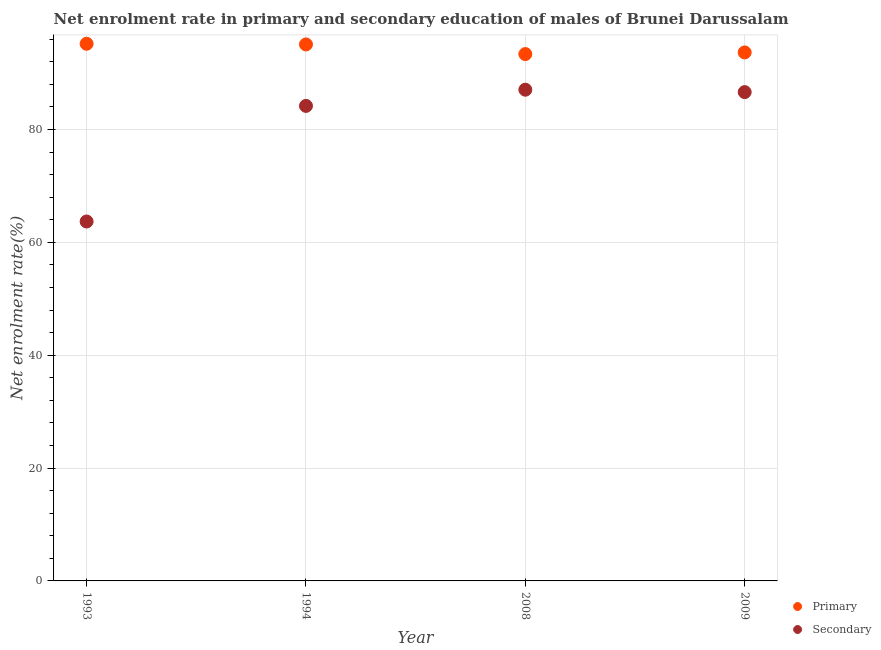How many different coloured dotlines are there?
Provide a succinct answer. 2. What is the enrollment rate in secondary education in 1993?
Ensure brevity in your answer.  63.7. Across all years, what is the maximum enrollment rate in primary education?
Your answer should be compact. 95.19. Across all years, what is the minimum enrollment rate in secondary education?
Offer a very short reply. 63.7. In which year was the enrollment rate in primary education minimum?
Give a very brief answer. 2008. What is the total enrollment rate in secondary education in the graph?
Offer a terse response. 321.56. What is the difference between the enrollment rate in primary education in 1994 and that in 2008?
Offer a very short reply. 1.71. What is the difference between the enrollment rate in primary education in 1993 and the enrollment rate in secondary education in 2008?
Your answer should be very brief. 8.14. What is the average enrollment rate in primary education per year?
Make the answer very short. 94.32. In the year 1994, what is the difference between the enrollment rate in primary education and enrollment rate in secondary education?
Your response must be concise. 10.89. In how many years, is the enrollment rate in primary education greater than 24 %?
Offer a terse response. 4. What is the ratio of the enrollment rate in primary education in 1994 to that in 2009?
Keep it short and to the point. 1.02. Is the enrollment rate in primary education in 1993 less than that in 2008?
Offer a terse response. No. What is the difference between the highest and the second highest enrollment rate in secondary education?
Ensure brevity in your answer.  0.43. What is the difference between the highest and the lowest enrollment rate in secondary education?
Give a very brief answer. 23.35. Is the enrollment rate in secondary education strictly less than the enrollment rate in primary education over the years?
Provide a short and direct response. Yes. How many dotlines are there?
Keep it short and to the point. 2. How many years are there in the graph?
Your answer should be very brief. 4. How many legend labels are there?
Keep it short and to the point. 2. What is the title of the graph?
Make the answer very short. Net enrolment rate in primary and secondary education of males of Brunei Darussalam. What is the label or title of the X-axis?
Your response must be concise. Year. What is the label or title of the Y-axis?
Ensure brevity in your answer.  Net enrolment rate(%). What is the Net enrolment rate(%) in Primary in 1993?
Offer a very short reply. 95.19. What is the Net enrolment rate(%) of Secondary in 1993?
Provide a succinct answer. 63.7. What is the Net enrolment rate(%) of Primary in 1994?
Your answer should be very brief. 95.08. What is the Net enrolment rate(%) of Secondary in 1994?
Provide a succinct answer. 84.18. What is the Net enrolment rate(%) in Primary in 2008?
Your response must be concise. 93.37. What is the Net enrolment rate(%) of Secondary in 2008?
Give a very brief answer. 87.05. What is the Net enrolment rate(%) of Primary in 2009?
Give a very brief answer. 93.66. What is the Net enrolment rate(%) of Secondary in 2009?
Provide a succinct answer. 86.63. Across all years, what is the maximum Net enrolment rate(%) of Primary?
Your answer should be very brief. 95.19. Across all years, what is the maximum Net enrolment rate(%) in Secondary?
Keep it short and to the point. 87.05. Across all years, what is the minimum Net enrolment rate(%) in Primary?
Provide a short and direct response. 93.37. Across all years, what is the minimum Net enrolment rate(%) in Secondary?
Your answer should be compact. 63.7. What is the total Net enrolment rate(%) of Primary in the graph?
Provide a succinct answer. 377.3. What is the total Net enrolment rate(%) of Secondary in the graph?
Your answer should be very brief. 321.56. What is the difference between the Net enrolment rate(%) of Primary in 1993 and that in 1994?
Make the answer very short. 0.12. What is the difference between the Net enrolment rate(%) in Secondary in 1993 and that in 1994?
Ensure brevity in your answer.  -20.49. What is the difference between the Net enrolment rate(%) of Primary in 1993 and that in 2008?
Offer a terse response. 1.83. What is the difference between the Net enrolment rate(%) of Secondary in 1993 and that in 2008?
Give a very brief answer. -23.35. What is the difference between the Net enrolment rate(%) of Primary in 1993 and that in 2009?
Ensure brevity in your answer.  1.54. What is the difference between the Net enrolment rate(%) in Secondary in 1993 and that in 2009?
Your answer should be compact. -22.93. What is the difference between the Net enrolment rate(%) in Primary in 1994 and that in 2008?
Your answer should be very brief. 1.71. What is the difference between the Net enrolment rate(%) of Secondary in 1994 and that in 2008?
Provide a succinct answer. -2.87. What is the difference between the Net enrolment rate(%) of Primary in 1994 and that in 2009?
Your response must be concise. 1.42. What is the difference between the Net enrolment rate(%) in Secondary in 1994 and that in 2009?
Keep it short and to the point. -2.44. What is the difference between the Net enrolment rate(%) of Primary in 2008 and that in 2009?
Provide a short and direct response. -0.29. What is the difference between the Net enrolment rate(%) of Secondary in 2008 and that in 2009?
Keep it short and to the point. 0.43. What is the difference between the Net enrolment rate(%) of Primary in 1993 and the Net enrolment rate(%) of Secondary in 1994?
Provide a short and direct response. 11.01. What is the difference between the Net enrolment rate(%) of Primary in 1993 and the Net enrolment rate(%) of Secondary in 2008?
Offer a very short reply. 8.14. What is the difference between the Net enrolment rate(%) in Primary in 1993 and the Net enrolment rate(%) in Secondary in 2009?
Offer a terse response. 8.57. What is the difference between the Net enrolment rate(%) of Primary in 1994 and the Net enrolment rate(%) of Secondary in 2008?
Your answer should be compact. 8.02. What is the difference between the Net enrolment rate(%) in Primary in 1994 and the Net enrolment rate(%) in Secondary in 2009?
Make the answer very short. 8.45. What is the difference between the Net enrolment rate(%) in Primary in 2008 and the Net enrolment rate(%) in Secondary in 2009?
Ensure brevity in your answer.  6.74. What is the average Net enrolment rate(%) of Primary per year?
Offer a terse response. 94.32. What is the average Net enrolment rate(%) in Secondary per year?
Offer a terse response. 80.39. In the year 1993, what is the difference between the Net enrolment rate(%) of Primary and Net enrolment rate(%) of Secondary?
Provide a succinct answer. 31.5. In the year 1994, what is the difference between the Net enrolment rate(%) in Primary and Net enrolment rate(%) in Secondary?
Make the answer very short. 10.89. In the year 2008, what is the difference between the Net enrolment rate(%) of Primary and Net enrolment rate(%) of Secondary?
Ensure brevity in your answer.  6.31. In the year 2009, what is the difference between the Net enrolment rate(%) of Primary and Net enrolment rate(%) of Secondary?
Keep it short and to the point. 7.03. What is the ratio of the Net enrolment rate(%) in Secondary in 1993 to that in 1994?
Give a very brief answer. 0.76. What is the ratio of the Net enrolment rate(%) of Primary in 1993 to that in 2008?
Give a very brief answer. 1.02. What is the ratio of the Net enrolment rate(%) of Secondary in 1993 to that in 2008?
Make the answer very short. 0.73. What is the ratio of the Net enrolment rate(%) in Primary in 1993 to that in 2009?
Offer a very short reply. 1.02. What is the ratio of the Net enrolment rate(%) of Secondary in 1993 to that in 2009?
Provide a short and direct response. 0.74. What is the ratio of the Net enrolment rate(%) of Primary in 1994 to that in 2008?
Ensure brevity in your answer.  1.02. What is the ratio of the Net enrolment rate(%) in Secondary in 1994 to that in 2008?
Your answer should be compact. 0.97. What is the ratio of the Net enrolment rate(%) in Primary in 1994 to that in 2009?
Ensure brevity in your answer.  1.02. What is the ratio of the Net enrolment rate(%) in Secondary in 1994 to that in 2009?
Offer a terse response. 0.97. What is the ratio of the Net enrolment rate(%) of Primary in 2008 to that in 2009?
Give a very brief answer. 1. What is the difference between the highest and the second highest Net enrolment rate(%) in Primary?
Provide a succinct answer. 0.12. What is the difference between the highest and the second highest Net enrolment rate(%) in Secondary?
Your answer should be very brief. 0.43. What is the difference between the highest and the lowest Net enrolment rate(%) of Primary?
Provide a short and direct response. 1.83. What is the difference between the highest and the lowest Net enrolment rate(%) in Secondary?
Offer a terse response. 23.35. 